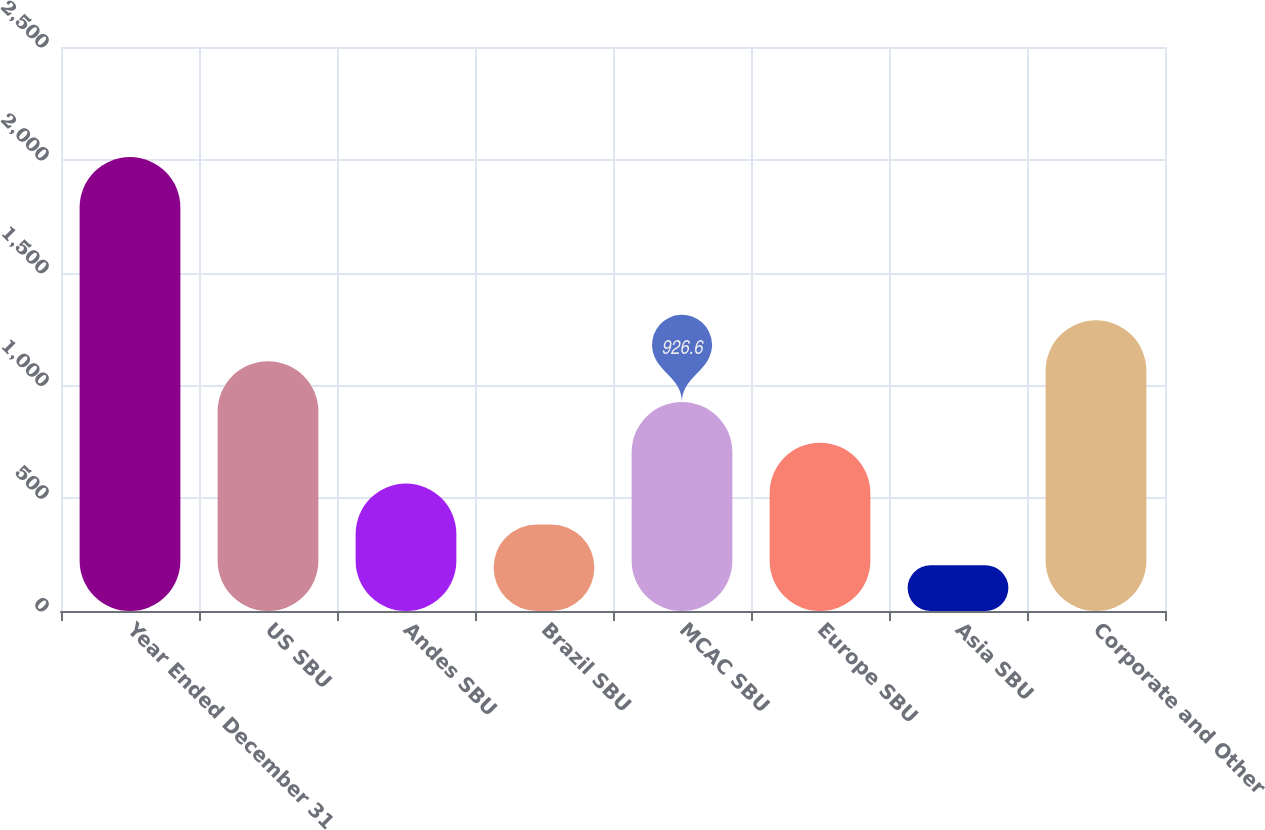Convert chart to OTSL. <chart><loc_0><loc_0><loc_500><loc_500><bar_chart><fcel>Year Ended December 31<fcel>US SBU<fcel>Andes SBU<fcel>Brazil SBU<fcel>MCAC SBU<fcel>Europe SBU<fcel>Asia SBU<fcel>Corporate and Other<nl><fcel>2012<fcel>1107.5<fcel>564.8<fcel>383.9<fcel>926.6<fcel>745.7<fcel>203<fcel>1288.4<nl></chart> 